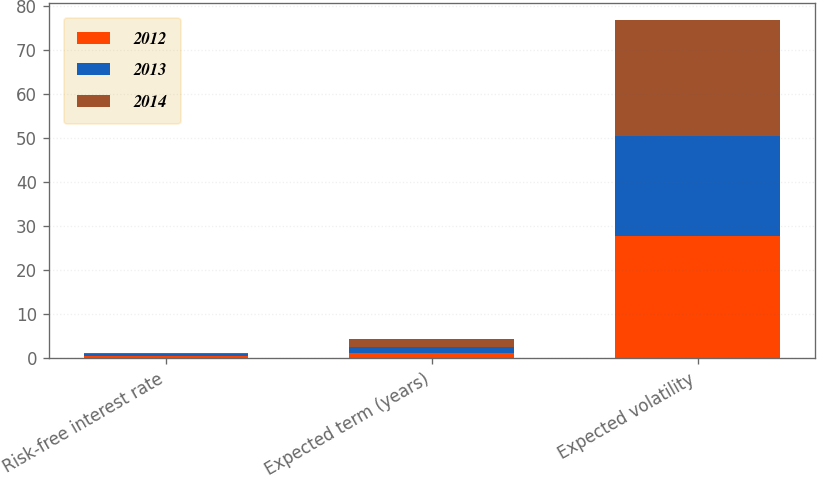Convert chart to OTSL. <chart><loc_0><loc_0><loc_500><loc_500><stacked_bar_chart><ecel><fcel>Risk-free interest rate<fcel>Expected term (years)<fcel>Expected volatility<nl><fcel>2012<fcel>0.59<fcel>1.3<fcel>27.72<nl><fcel>2013<fcel>0.45<fcel>1.38<fcel>22.77<nl><fcel>2014<fcel>0.29<fcel>1.63<fcel>26.31<nl></chart> 